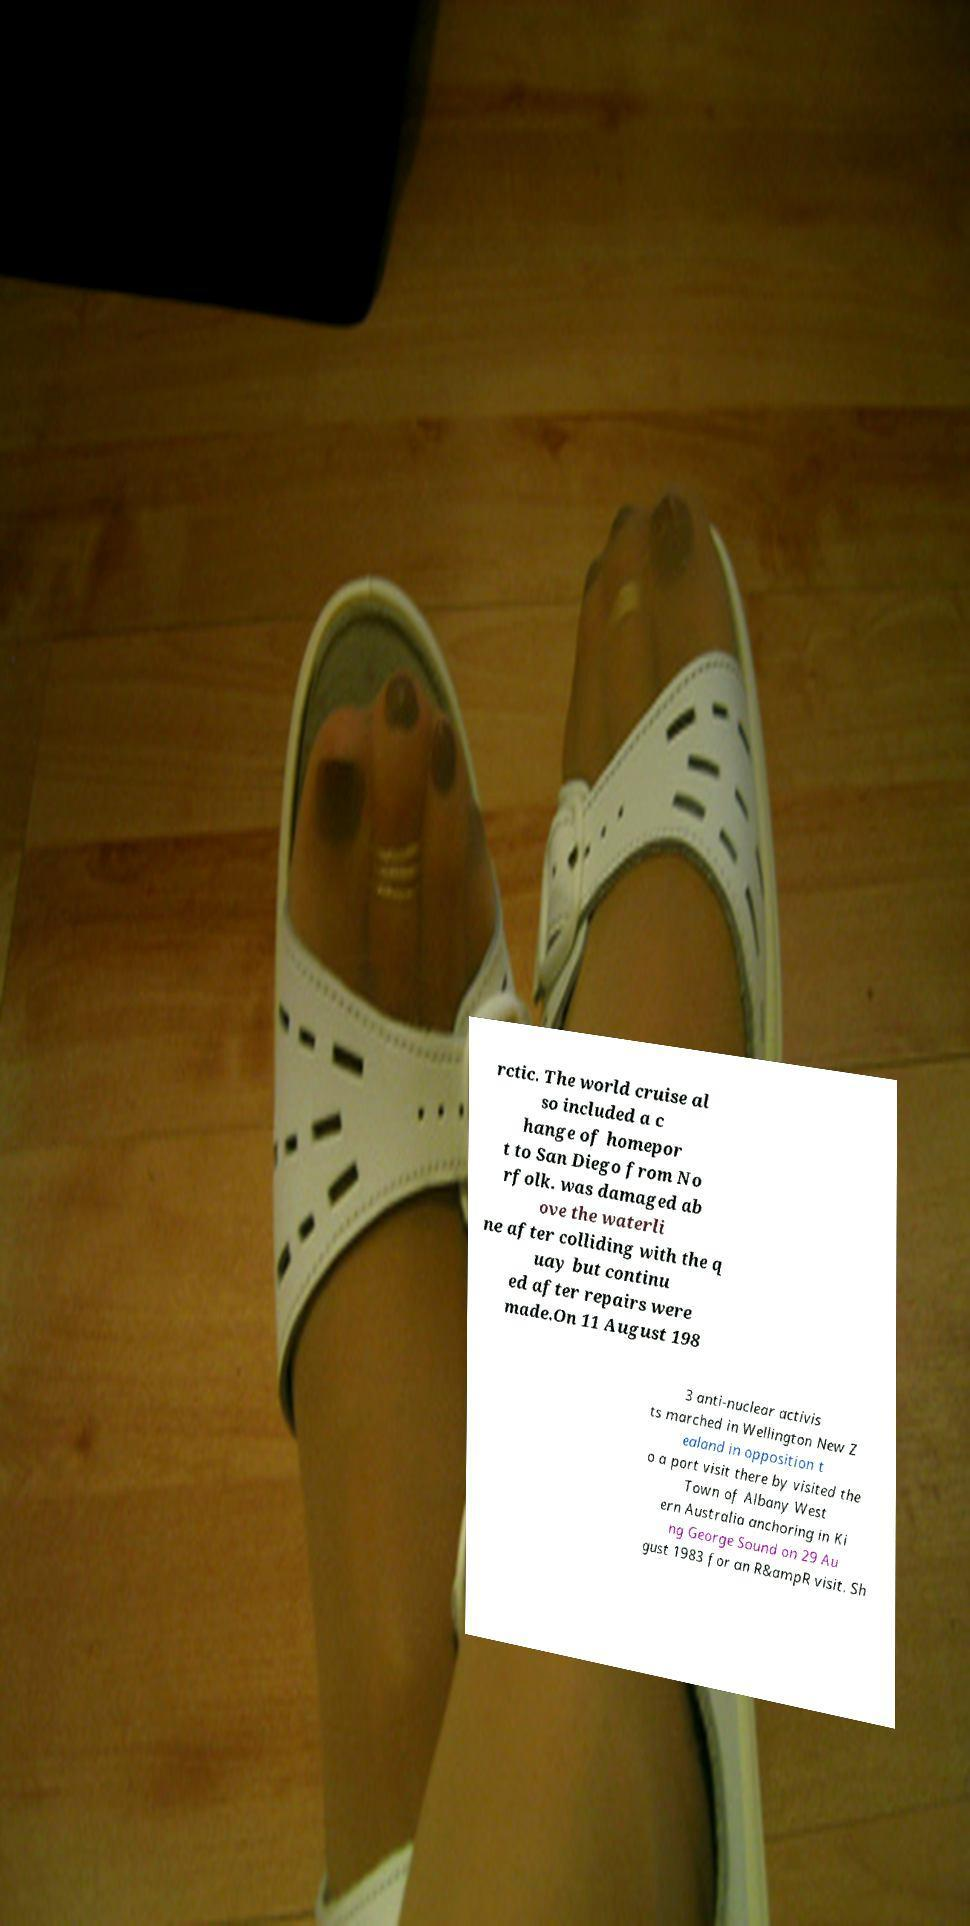Can you accurately transcribe the text from the provided image for me? rctic. The world cruise al so included a c hange of homepor t to San Diego from No rfolk. was damaged ab ove the waterli ne after colliding with the q uay but continu ed after repairs were made.On 11 August 198 3 anti-nuclear activis ts marched in Wellington New Z ealand in opposition t o a port visit there by visited the Town of Albany West ern Australia anchoring in Ki ng George Sound on 29 Au gust 1983 for an R&ampR visit. Sh 